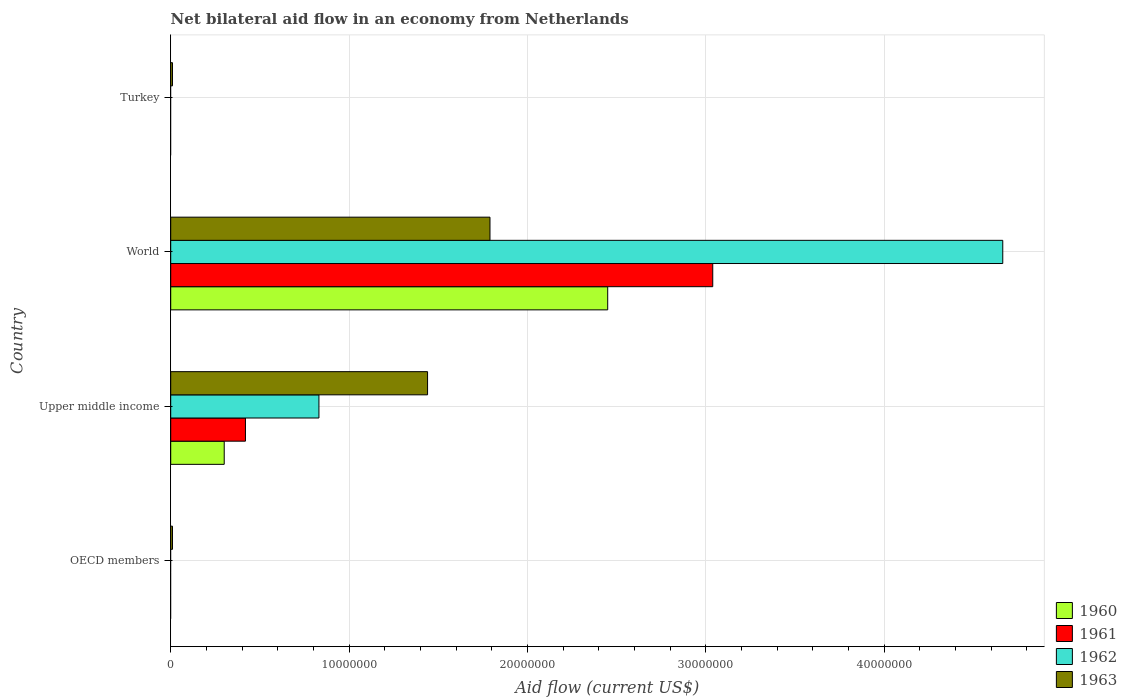How many different coloured bars are there?
Your answer should be very brief. 4. How many bars are there on the 1st tick from the bottom?
Your response must be concise. 1. What is the label of the 3rd group of bars from the top?
Provide a succinct answer. Upper middle income. Across all countries, what is the maximum net bilateral aid flow in 1963?
Provide a short and direct response. 1.79e+07. In which country was the net bilateral aid flow in 1960 maximum?
Your answer should be very brief. World. What is the total net bilateral aid flow in 1963 in the graph?
Provide a succinct answer. 3.25e+07. What is the difference between the net bilateral aid flow in 1963 in Upper middle income and that in World?
Provide a short and direct response. -3.50e+06. What is the difference between the net bilateral aid flow in 1961 in World and the net bilateral aid flow in 1960 in Upper middle income?
Your response must be concise. 2.74e+07. What is the average net bilateral aid flow in 1962 per country?
Make the answer very short. 1.37e+07. What is the difference between the net bilateral aid flow in 1960 and net bilateral aid flow in 1961 in Upper middle income?
Offer a very short reply. -1.19e+06. What is the difference between the highest and the second highest net bilateral aid flow in 1963?
Your response must be concise. 3.50e+06. What is the difference between the highest and the lowest net bilateral aid flow in 1961?
Offer a very short reply. 3.04e+07. Is the sum of the net bilateral aid flow in 1962 in Upper middle income and World greater than the maximum net bilateral aid flow in 1961 across all countries?
Keep it short and to the point. Yes. Is it the case that in every country, the sum of the net bilateral aid flow in 1961 and net bilateral aid flow in 1963 is greater than the sum of net bilateral aid flow in 1962 and net bilateral aid flow in 1960?
Your answer should be compact. No. Is it the case that in every country, the sum of the net bilateral aid flow in 1960 and net bilateral aid flow in 1962 is greater than the net bilateral aid flow in 1961?
Make the answer very short. No. What is the difference between two consecutive major ticks on the X-axis?
Give a very brief answer. 1.00e+07. Are the values on the major ticks of X-axis written in scientific E-notation?
Your response must be concise. No. Does the graph contain any zero values?
Provide a short and direct response. Yes. Does the graph contain grids?
Ensure brevity in your answer.  Yes. What is the title of the graph?
Give a very brief answer. Net bilateral aid flow in an economy from Netherlands. What is the Aid flow (current US$) in 1960 in OECD members?
Your response must be concise. 0. What is the Aid flow (current US$) in 1962 in OECD members?
Your answer should be compact. 0. What is the Aid flow (current US$) of 1963 in OECD members?
Your answer should be very brief. 1.00e+05. What is the Aid flow (current US$) of 1961 in Upper middle income?
Make the answer very short. 4.19e+06. What is the Aid flow (current US$) in 1962 in Upper middle income?
Your response must be concise. 8.31e+06. What is the Aid flow (current US$) of 1963 in Upper middle income?
Your answer should be compact. 1.44e+07. What is the Aid flow (current US$) of 1960 in World?
Make the answer very short. 2.45e+07. What is the Aid flow (current US$) of 1961 in World?
Ensure brevity in your answer.  3.04e+07. What is the Aid flow (current US$) of 1962 in World?
Provide a short and direct response. 4.66e+07. What is the Aid flow (current US$) in 1963 in World?
Give a very brief answer. 1.79e+07. What is the Aid flow (current US$) of 1960 in Turkey?
Your answer should be very brief. 0. What is the Aid flow (current US$) of 1961 in Turkey?
Your response must be concise. 0. What is the Aid flow (current US$) of 1962 in Turkey?
Ensure brevity in your answer.  0. Across all countries, what is the maximum Aid flow (current US$) of 1960?
Your response must be concise. 2.45e+07. Across all countries, what is the maximum Aid flow (current US$) in 1961?
Keep it short and to the point. 3.04e+07. Across all countries, what is the maximum Aid flow (current US$) in 1962?
Provide a succinct answer. 4.66e+07. Across all countries, what is the maximum Aid flow (current US$) in 1963?
Your answer should be compact. 1.79e+07. Across all countries, what is the minimum Aid flow (current US$) of 1960?
Your answer should be very brief. 0. Across all countries, what is the minimum Aid flow (current US$) in 1962?
Provide a succinct answer. 0. What is the total Aid flow (current US$) in 1960 in the graph?
Provide a short and direct response. 2.75e+07. What is the total Aid flow (current US$) of 1961 in the graph?
Provide a short and direct response. 3.46e+07. What is the total Aid flow (current US$) of 1962 in the graph?
Provide a short and direct response. 5.50e+07. What is the total Aid flow (current US$) in 1963 in the graph?
Your answer should be very brief. 3.25e+07. What is the difference between the Aid flow (current US$) in 1963 in OECD members and that in Upper middle income?
Offer a very short reply. -1.43e+07. What is the difference between the Aid flow (current US$) of 1963 in OECD members and that in World?
Offer a terse response. -1.78e+07. What is the difference between the Aid flow (current US$) in 1963 in OECD members and that in Turkey?
Your answer should be very brief. 0. What is the difference between the Aid flow (current US$) in 1960 in Upper middle income and that in World?
Your answer should be compact. -2.15e+07. What is the difference between the Aid flow (current US$) of 1961 in Upper middle income and that in World?
Offer a very short reply. -2.62e+07. What is the difference between the Aid flow (current US$) of 1962 in Upper middle income and that in World?
Your answer should be compact. -3.83e+07. What is the difference between the Aid flow (current US$) of 1963 in Upper middle income and that in World?
Your response must be concise. -3.50e+06. What is the difference between the Aid flow (current US$) in 1963 in Upper middle income and that in Turkey?
Give a very brief answer. 1.43e+07. What is the difference between the Aid flow (current US$) in 1963 in World and that in Turkey?
Keep it short and to the point. 1.78e+07. What is the difference between the Aid flow (current US$) in 1960 in Upper middle income and the Aid flow (current US$) in 1961 in World?
Make the answer very short. -2.74e+07. What is the difference between the Aid flow (current US$) in 1960 in Upper middle income and the Aid flow (current US$) in 1962 in World?
Provide a short and direct response. -4.36e+07. What is the difference between the Aid flow (current US$) in 1960 in Upper middle income and the Aid flow (current US$) in 1963 in World?
Ensure brevity in your answer.  -1.49e+07. What is the difference between the Aid flow (current US$) of 1961 in Upper middle income and the Aid flow (current US$) of 1962 in World?
Your answer should be very brief. -4.25e+07. What is the difference between the Aid flow (current US$) in 1961 in Upper middle income and the Aid flow (current US$) in 1963 in World?
Offer a terse response. -1.37e+07. What is the difference between the Aid flow (current US$) in 1962 in Upper middle income and the Aid flow (current US$) in 1963 in World?
Offer a terse response. -9.59e+06. What is the difference between the Aid flow (current US$) of 1960 in Upper middle income and the Aid flow (current US$) of 1963 in Turkey?
Keep it short and to the point. 2.90e+06. What is the difference between the Aid flow (current US$) in 1961 in Upper middle income and the Aid flow (current US$) in 1963 in Turkey?
Offer a terse response. 4.09e+06. What is the difference between the Aid flow (current US$) of 1962 in Upper middle income and the Aid flow (current US$) of 1963 in Turkey?
Your answer should be compact. 8.21e+06. What is the difference between the Aid flow (current US$) of 1960 in World and the Aid flow (current US$) of 1963 in Turkey?
Offer a very short reply. 2.44e+07. What is the difference between the Aid flow (current US$) in 1961 in World and the Aid flow (current US$) in 1963 in Turkey?
Your answer should be compact. 3.03e+07. What is the difference between the Aid flow (current US$) of 1962 in World and the Aid flow (current US$) of 1963 in Turkey?
Offer a terse response. 4.66e+07. What is the average Aid flow (current US$) in 1960 per country?
Offer a terse response. 6.88e+06. What is the average Aid flow (current US$) of 1961 per country?
Provide a short and direct response. 8.64e+06. What is the average Aid flow (current US$) in 1962 per country?
Keep it short and to the point. 1.37e+07. What is the average Aid flow (current US$) of 1963 per country?
Your answer should be compact. 8.12e+06. What is the difference between the Aid flow (current US$) of 1960 and Aid flow (current US$) of 1961 in Upper middle income?
Offer a terse response. -1.19e+06. What is the difference between the Aid flow (current US$) of 1960 and Aid flow (current US$) of 1962 in Upper middle income?
Your answer should be very brief. -5.31e+06. What is the difference between the Aid flow (current US$) of 1960 and Aid flow (current US$) of 1963 in Upper middle income?
Keep it short and to the point. -1.14e+07. What is the difference between the Aid flow (current US$) in 1961 and Aid flow (current US$) in 1962 in Upper middle income?
Give a very brief answer. -4.12e+06. What is the difference between the Aid flow (current US$) in 1961 and Aid flow (current US$) in 1963 in Upper middle income?
Your answer should be very brief. -1.02e+07. What is the difference between the Aid flow (current US$) of 1962 and Aid flow (current US$) of 1963 in Upper middle income?
Your response must be concise. -6.09e+06. What is the difference between the Aid flow (current US$) in 1960 and Aid flow (current US$) in 1961 in World?
Keep it short and to the point. -5.89e+06. What is the difference between the Aid flow (current US$) of 1960 and Aid flow (current US$) of 1962 in World?
Offer a very short reply. -2.22e+07. What is the difference between the Aid flow (current US$) in 1960 and Aid flow (current US$) in 1963 in World?
Offer a very short reply. 6.60e+06. What is the difference between the Aid flow (current US$) of 1961 and Aid flow (current US$) of 1962 in World?
Make the answer very short. -1.63e+07. What is the difference between the Aid flow (current US$) of 1961 and Aid flow (current US$) of 1963 in World?
Your response must be concise. 1.25e+07. What is the difference between the Aid flow (current US$) in 1962 and Aid flow (current US$) in 1963 in World?
Give a very brief answer. 2.88e+07. What is the ratio of the Aid flow (current US$) of 1963 in OECD members to that in Upper middle income?
Keep it short and to the point. 0.01. What is the ratio of the Aid flow (current US$) of 1963 in OECD members to that in World?
Offer a terse response. 0.01. What is the ratio of the Aid flow (current US$) in 1960 in Upper middle income to that in World?
Make the answer very short. 0.12. What is the ratio of the Aid flow (current US$) in 1961 in Upper middle income to that in World?
Offer a terse response. 0.14. What is the ratio of the Aid flow (current US$) of 1962 in Upper middle income to that in World?
Give a very brief answer. 0.18. What is the ratio of the Aid flow (current US$) in 1963 in Upper middle income to that in World?
Your answer should be compact. 0.8. What is the ratio of the Aid flow (current US$) in 1963 in Upper middle income to that in Turkey?
Your answer should be compact. 144. What is the ratio of the Aid flow (current US$) in 1963 in World to that in Turkey?
Your response must be concise. 179. What is the difference between the highest and the second highest Aid flow (current US$) in 1963?
Your response must be concise. 3.50e+06. What is the difference between the highest and the lowest Aid flow (current US$) in 1960?
Your answer should be very brief. 2.45e+07. What is the difference between the highest and the lowest Aid flow (current US$) of 1961?
Keep it short and to the point. 3.04e+07. What is the difference between the highest and the lowest Aid flow (current US$) in 1962?
Offer a terse response. 4.66e+07. What is the difference between the highest and the lowest Aid flow (current US$) in 1963?
Ensure brevity in your answer.  1.78e+07. 